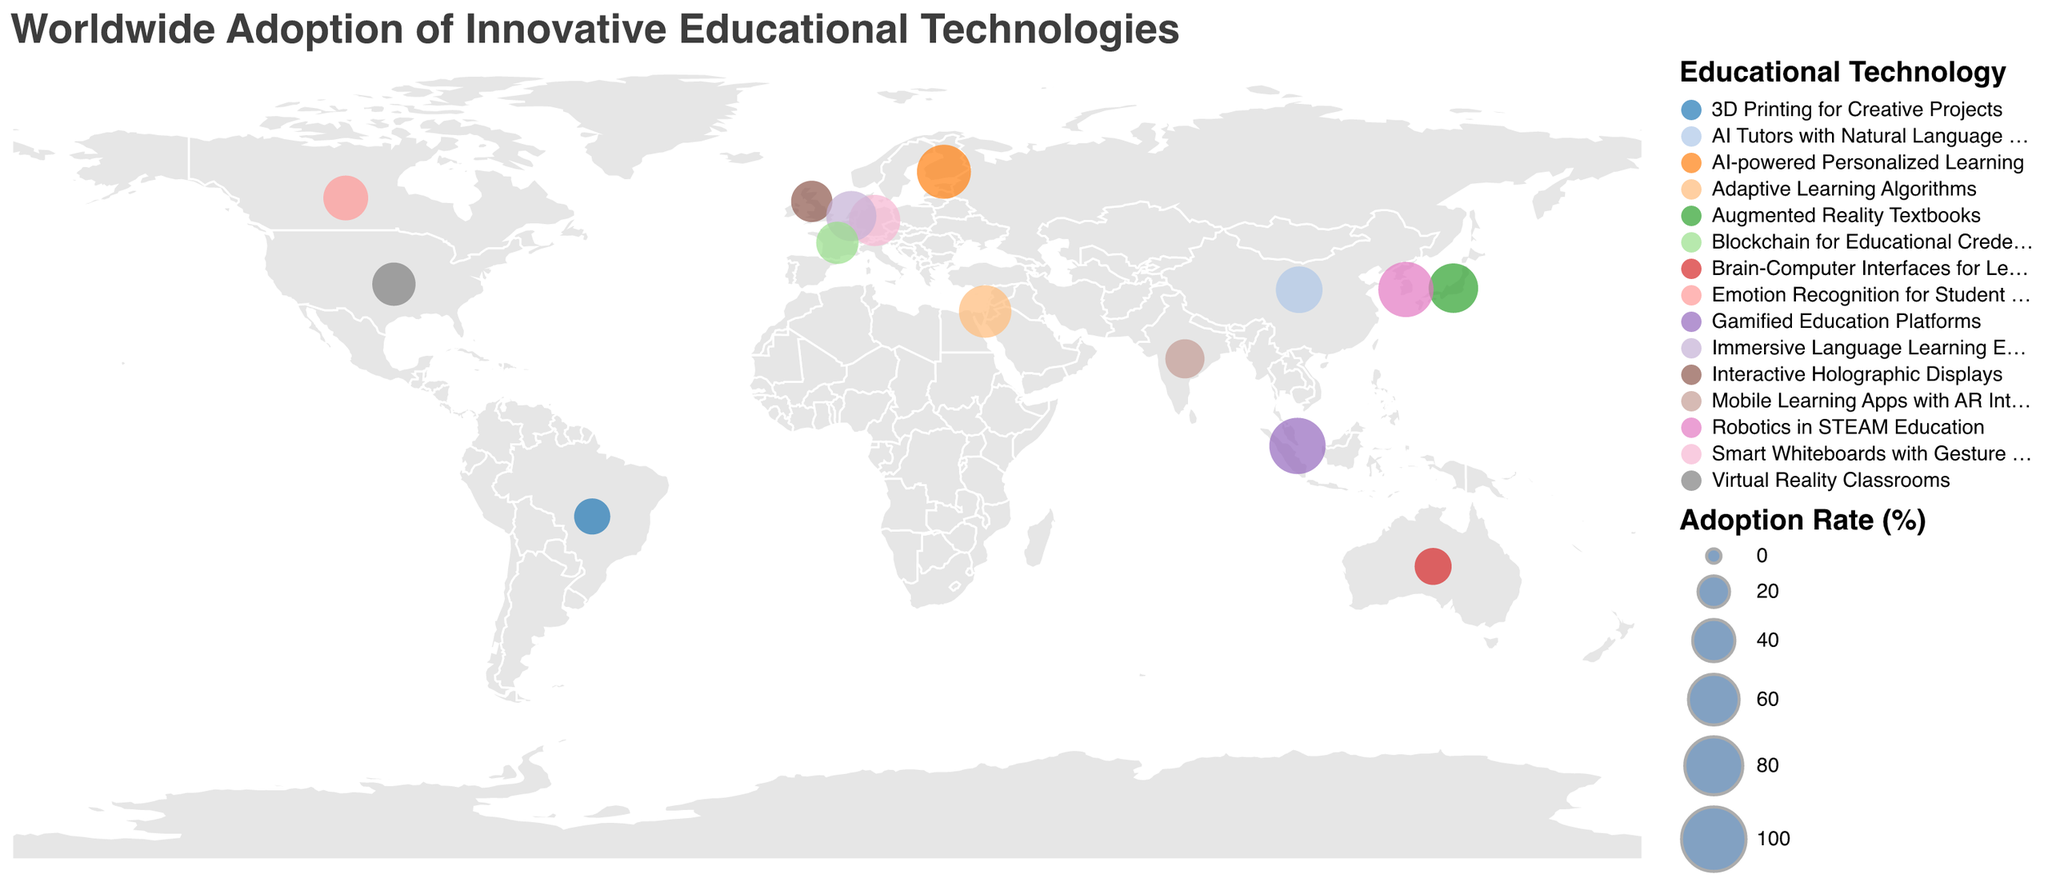What is the title of the plot? The title is displayed at the top of the plot. It reads "Worldwide Adoption of Innovative Educational Technologies".
Answer: Worldwide Adoption of Innovative Educational Technologies Which country has the highest adoption rate of educational technology? By examining the size of the circles representing adoption rates, Singapore has the largest circle indicating the highest rate of 75.2%.
Answer: Singapore What technology is most widely adopted in Japan? The tooltip or legend indicates that Japan has adopted Augmented Reality Textbooks as seen in the corresponding circle on the map.
Answer: Augmented Reality Textbooks How many countries have an adoption rate greater than 60%? By looking at the size and labels of the circles, four countries (Finland, Singapore, South Korea, Germany) have adoption rates above 60%.
Answer: Four Compare the adoption rate of Educational technologies in India and China. Which country has a higher rate? By comparing the sizes of the circles and their labels, China (50.1%) has a higher adoption rate than India (33.7%).
Answer: China What is the average adoption rate of the listed technologies in European countries? The European countries listed are Finland, United Kingdom, Germany, Netherlands, and France. Their rates are 68.7, 38.1, 61.4, 58.6, and 40.2. The average is (68.7 + 38.1 + 61.4 + 58.6 + 40.2) / 5 = 53.4%.
Answer: 53.4% Which country in the Americas has adopted Emotion Recognition for Student Engagement, and what is its adoption rate? Looking at the tooltips or geographical labels, Canada in the Americas has adopted this technology with an adoption rate of 45.8%.
Answer: Canada, 45.8% What's the most innovative educational technology adopted by Brazil, and what is their adoption rate? The tooltip indicates Brazil has adopted 3D Printing for Creative Projects with an adoption rate of 27.9%.
Answer: 3D Printing for Creative Projects, 27.9% What African country might be in the dataset based on the displayed data point locations and technologies? According to the map, no data points are shown in the African region for the listed technologies, indicating no African countries are in the dataset.
Answer: None Which continent shows the highest diversity in adopting different educational technologies? By visually tracking the technologies assigned to different countries, Asia has the highest diversity with technologies like AI Tutors, Robotics, Augmented Reality Textbooks, Gamified Education Platforms, etc.
Answer: Asia 